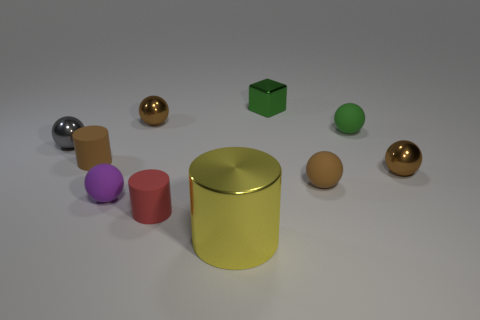Subtract all matte cylinders. How many cylinders are left? 1 Subtract all brown cylinders. How many cylinders are left? 2 Subtract all purple cylinders. How many green balls are left? 1 Subtract all small green objects. Subtract all brown matte objects. How many objects are left? 6 Add 3 big things. How many big things are left? 4 Add 6 green shiny things. How many green shiny things exist? 7 Subtract 3 brown spheres. How many objects are left? 7 Subtract all cylinders. How many objects are left? 7 Subtract 2 cylinders. How many cylinders are left? 1 Subtract all brown blocks. Subtract all brown cylinders. How many blocks are left? 1 